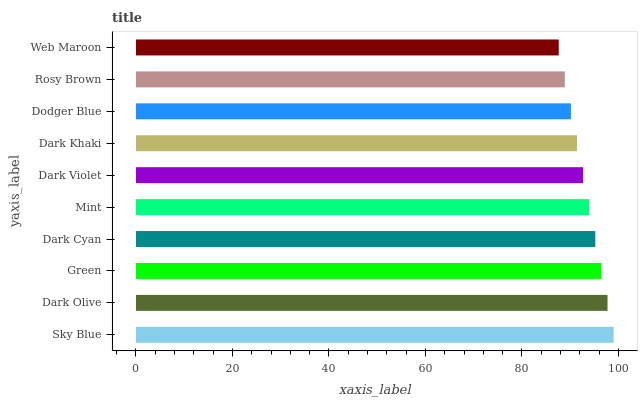Is Web Maroon the minimum?
Answer yes or no. Yes. Is Sky Blue the maximum?
Answer yes or no. Yes. Is Dark Olive the minimum?
Answer yes or no. No. Is Dark Olive the maximum?
Answer yes or no. No. Is Sky Blue greater than Dark Olive?
Answer yes or no. Yes. Is Dark Olive less than Sky Blue?
Answer yes or no. Yes. Is Dark Olive greater than Sky Blue?
Answer yes or no. No. Is Sky Blue less than Dark Olive?
Answer yes or no. No. Is Mint the high median?
Answer yes or no. Yes. Is Dark Violet the low median?
Answer yes or no. Yes. Is Web Maroon the high median?
Answer yes or no. No. Is Web Maroon the low median?
Answer yes or no. No. 